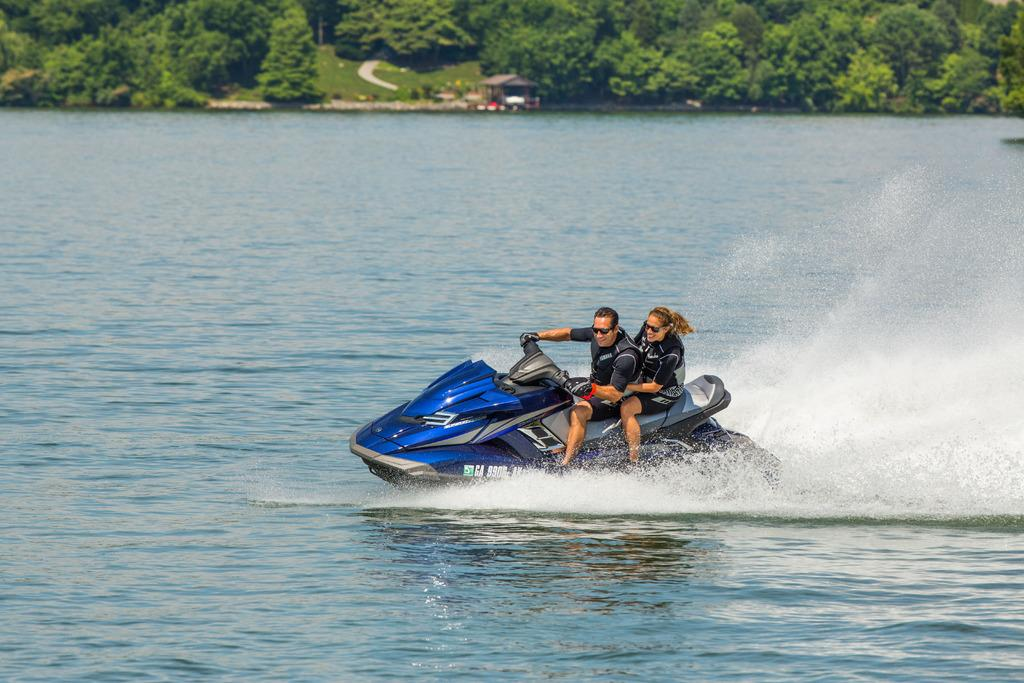Who is present in the image? There is a couple in the image. What are the couple doing in the image? The couple is riding a water bike in the image. What type of environment can be seen in the image? There is water and trees visible in the image. What type of string can be seen connecting the mice in the image? There are no mice or string present in the image. How many mittens can be seen on the couple's hands in the image? The couple is not wearing mittens in the image. 